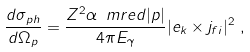<formula> <loc_0><loc_0><loc_500><loc_500>\frac { d \sigma _ { p h } } { d \Omega _ { p } } & = \frac { Z ^ { 2 } \alpha \, \ m r e d | p | } { 4 \pi E _ { \gamma } } | e _ { k } \times j _ { f i } | ^ { 2 } \ ,</formula> 